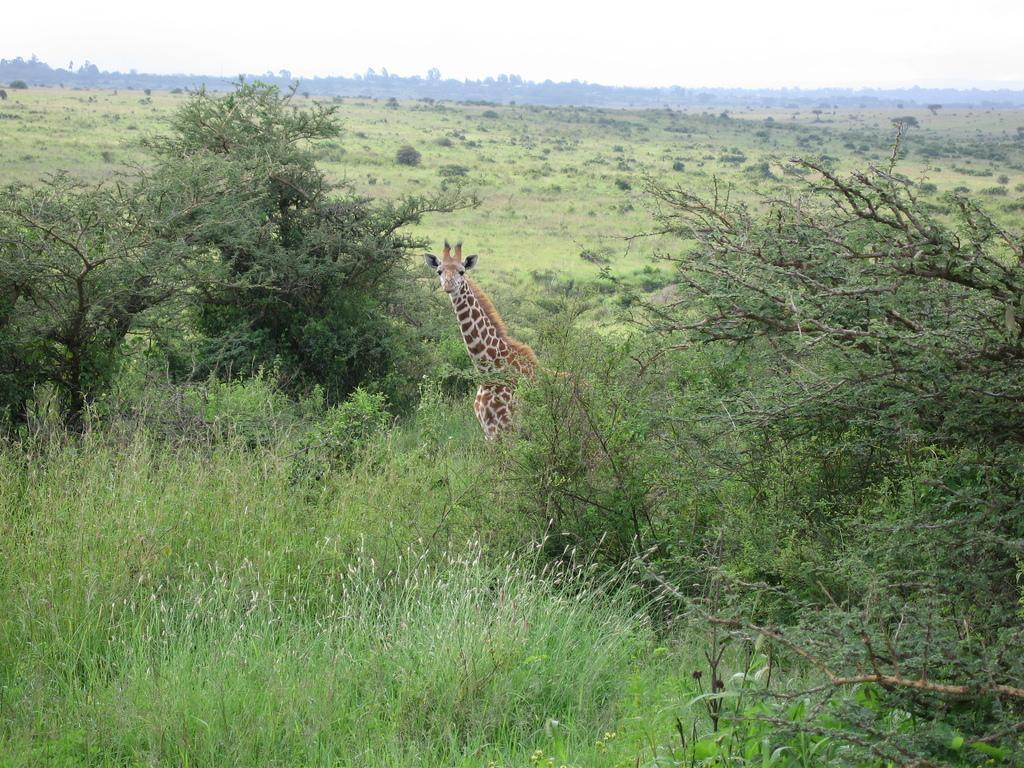Describe this image in one or two sentences. In the foreground we can see the grass. Here we can see a giraffe. Here we can see the trees on the left side and the right side as well. In the background, we can see the trees. 